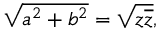Convert formula to latex. <formula><loc_0><loc_0><loc_500><loc_500>{ \sqrt { a ^ { 2 } + b ^ { 2 } } } = { \sqrt { z { \overline { z } } } } ,</formula> 